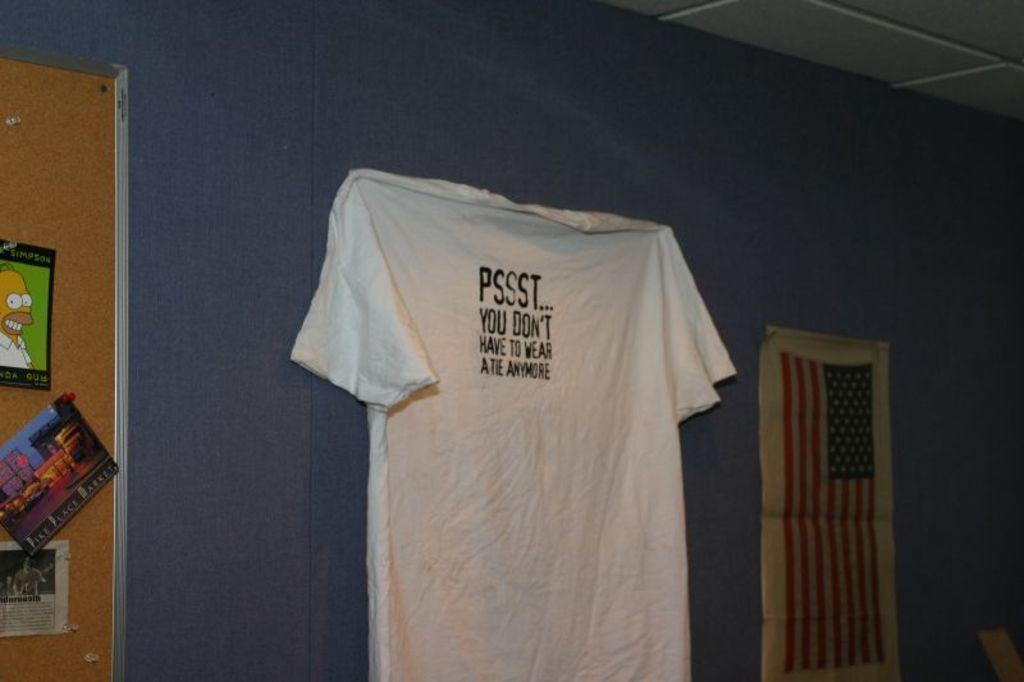Provide a one-sentence caption for the provided image. A tshirt hanging on the pall that read PSSST... 